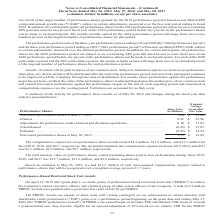From Conagra Brands's financial document, What were the total compensation expenses for performance share awards during fiscal 2017 and 2018, respectively? The document shows two values: $13.3 million and $11.8 million. From the document: "re awards totaled $8.2 million, $11.8 million, and $13.3 million for our performance share awards totaled $8.2 million, $11.8 million, and $13.3 milli..." Also, How much was the total unrecognized compensation expense related to performance shares? According to the financial document, $13.2 million. The relevant text states: "Based on estimates at May 26, 2019, we had $13.2 million of total unrecognized compensation expense related to..." Also, How many share units that are nonvested performance shares on May 27, 2018? According to the financial document, 1.00 (in millions). The relevant text states: "Nonvested performance shares at May 27, 2018 . 1.00 $ 33.40..." Also, can you calculate: What is the total price of performance shares that were granted or being adjusted for performance results attained and dividend equivalents? Based on the calculation: (0.45*35.96)+(0.18*31.03) , the result is 21.77 (in millions). This is based on the information: "Granted . 0.45 $ 35.96 Granted . 0.45 $ 35.96 ance results attained and dividend equivalents. . 0.18 $ 31.03 sults attained and dividend equivalents. . 0.18 $ 31.03..." The key data points involved are: 0.18, 0.45, 31.03. Also, can you calculate: What is the ratio of granted share units to forfeited share units? Based on the calculation: 0.45/0.05 , the result is 9. This is based on the information: "Forfeited . (0.05) $ 34.54 Granted . 0.45 $ 35.96..." The key data points involved are: 0.05, 0.45. Also, can you calculate: What is the ratio of the total price of nonvested performance shares to the total intrinsic value of vested performance shares during 2019?  To answer this question, I need to perform calculations using the financial data. The calculation is: (1.15*34.89)/15.7 , which equals 2.56. This is based on the information: "ested performance shares at May 26, 2019 . 1.15 $ 34.89 Nonvested performance shares at May 26, 2019 . 1.15 $ 34.89 2018, and 2017 was $15.7 million, $11.2 million, and $2.8 million, respectively...." The key data points involved are: 1.15, 15.7, 34.89. 